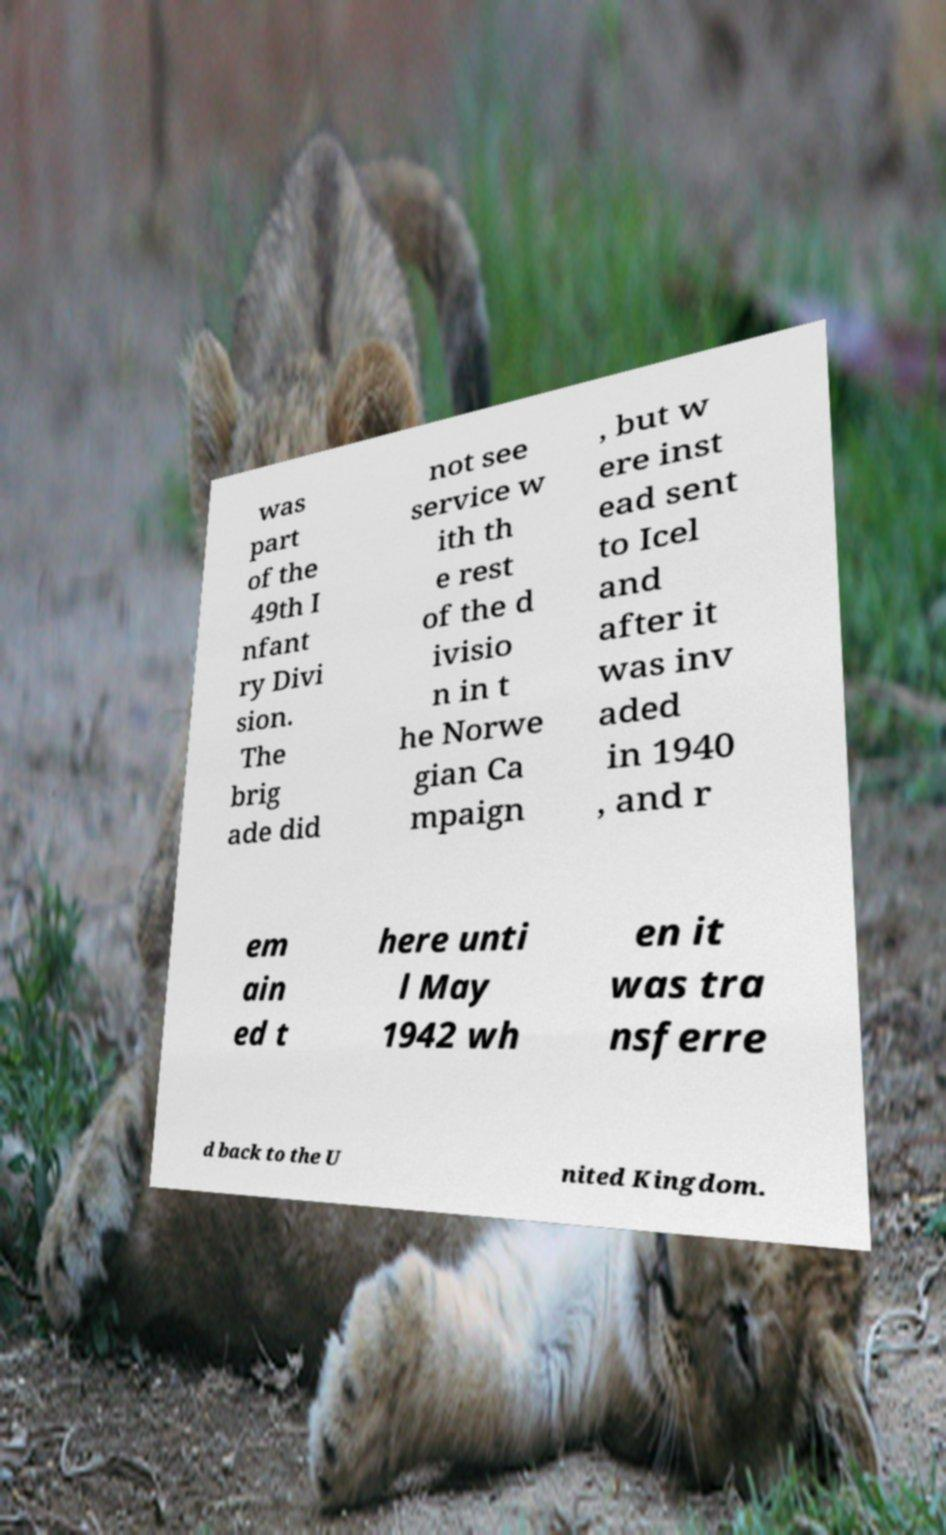Can you read and provide the text displayed in the image?This photo seems to have some interesting text. Can you extract and type it out for me? was part of the 49th I nfant ry Divi sion. The brig ade did not see service w ith th e rest of the d ivisio n in t he Norwe gian Ca mpaign , but w ere inst ead sent to Icel and after it was inv aded in 1940 , and r em ain ed t here unti l May 1942 wh en it was tra nsferre d back to the U nited Kingdom. 